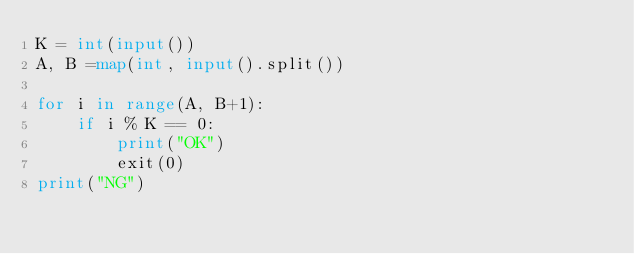<code> <loc_0><loc_0><loc_500><loc_500><_Python_>K = int(input())
A, B =map(int, input().split())

for i in range(A, B+1):
    if i % K == 0:
        print("OK")
        exit(0)
print("NG")


</code> 